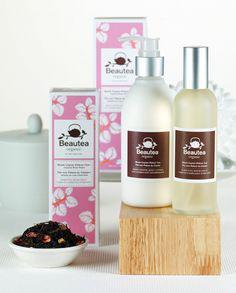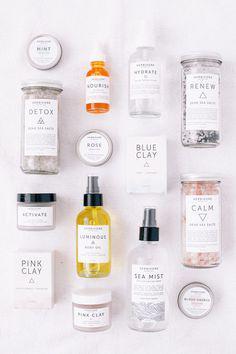The first image is the image on the left, the second image is the image on the right. For the images displayed, is the sentence "An image contains only two side-by-side products, which feature green in the packaging." factually correct? Answer yes or no. No. 